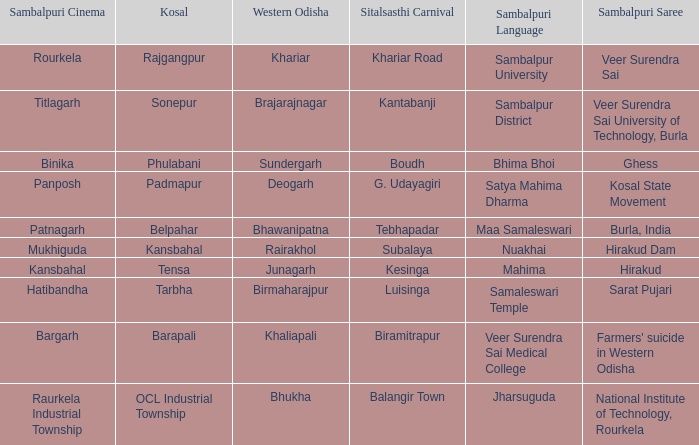What is the sitalsasthi carnival with sonepur as kosal? Kantabanji. 